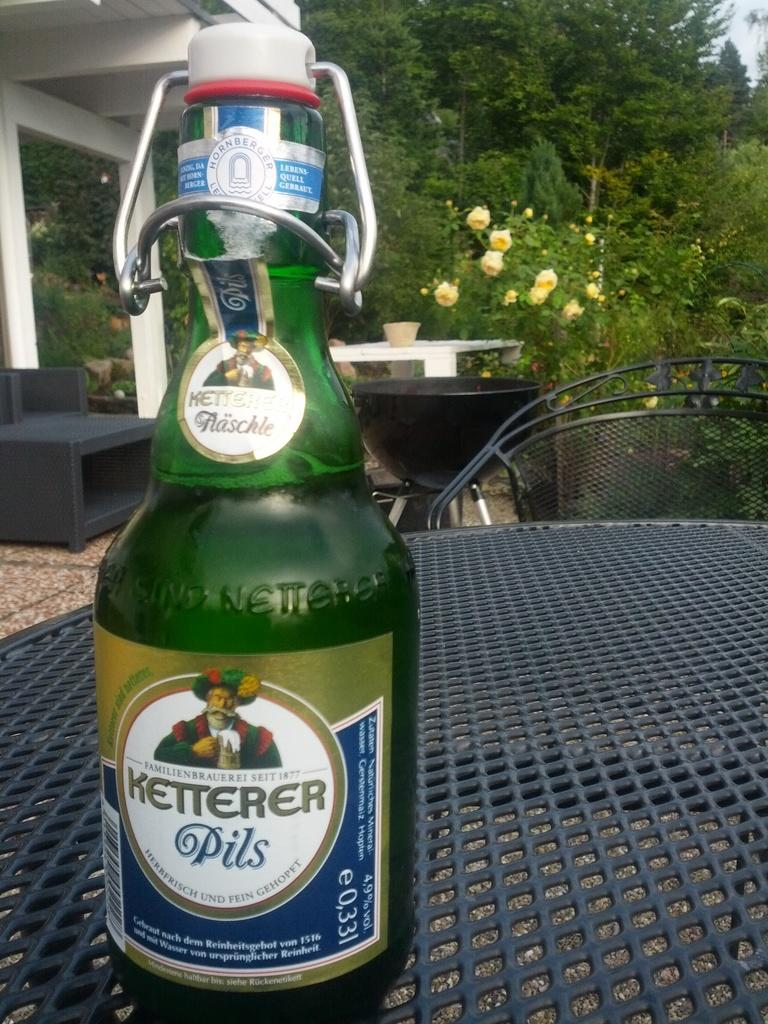Provide a one-sentence caption for the provided image. Green bottle of Ketterer pils drink outside on a table. 